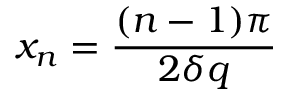<formula> <loc_0><loc_0><loc_500><loc_500>x _ { n } = \frac { ( n - 1 ) \pi } { 2 \delta q }</formula> 